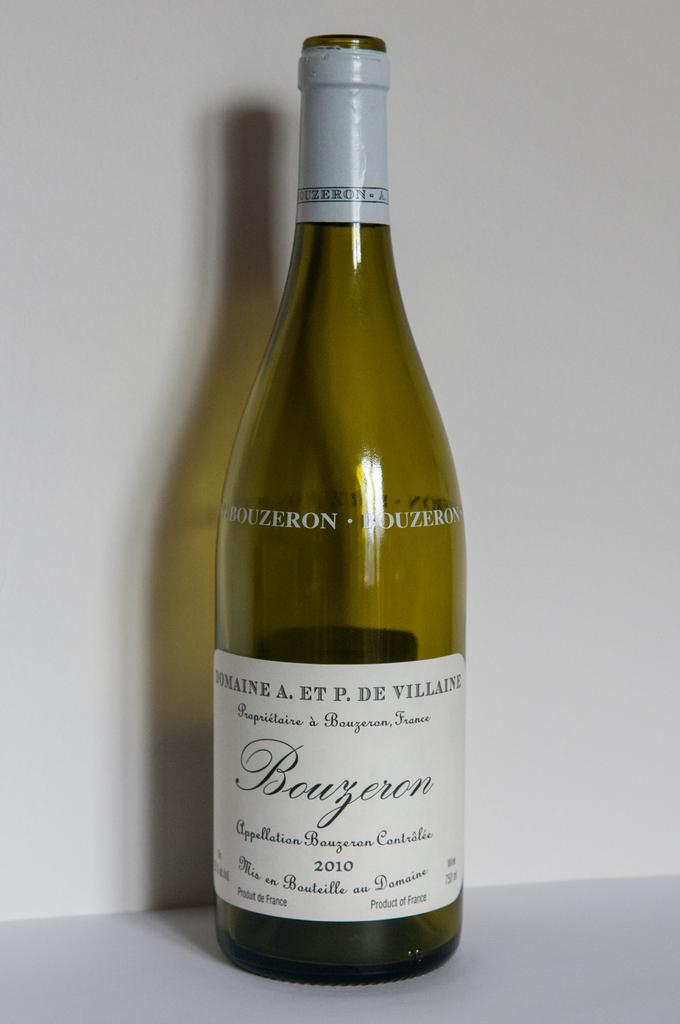<image>
Present a compact description of the photo's key features. The white wine was produced and bottled in 2010. 